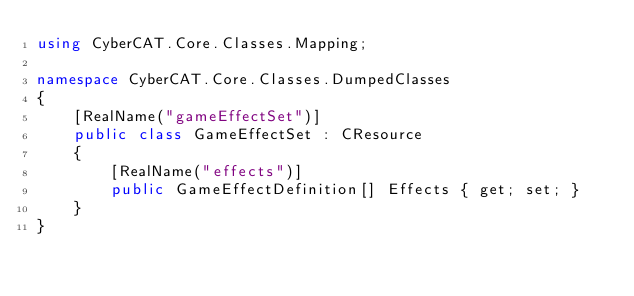Convert code to text. <code><loc_0><loc_0><loc_500><loc_500><_C#_>using CyberCAT.Core.Classes.Mapping;

namespace CyberCAT.Core.Classes.DumpedClasses
{
    [RealName("gameEffectSet")]
    public class GameEffectSet : CResource
    {
        [RealName("effects")]
        public GameEffectDefinition[] Effects { get; set; }
    }
}
</code> 